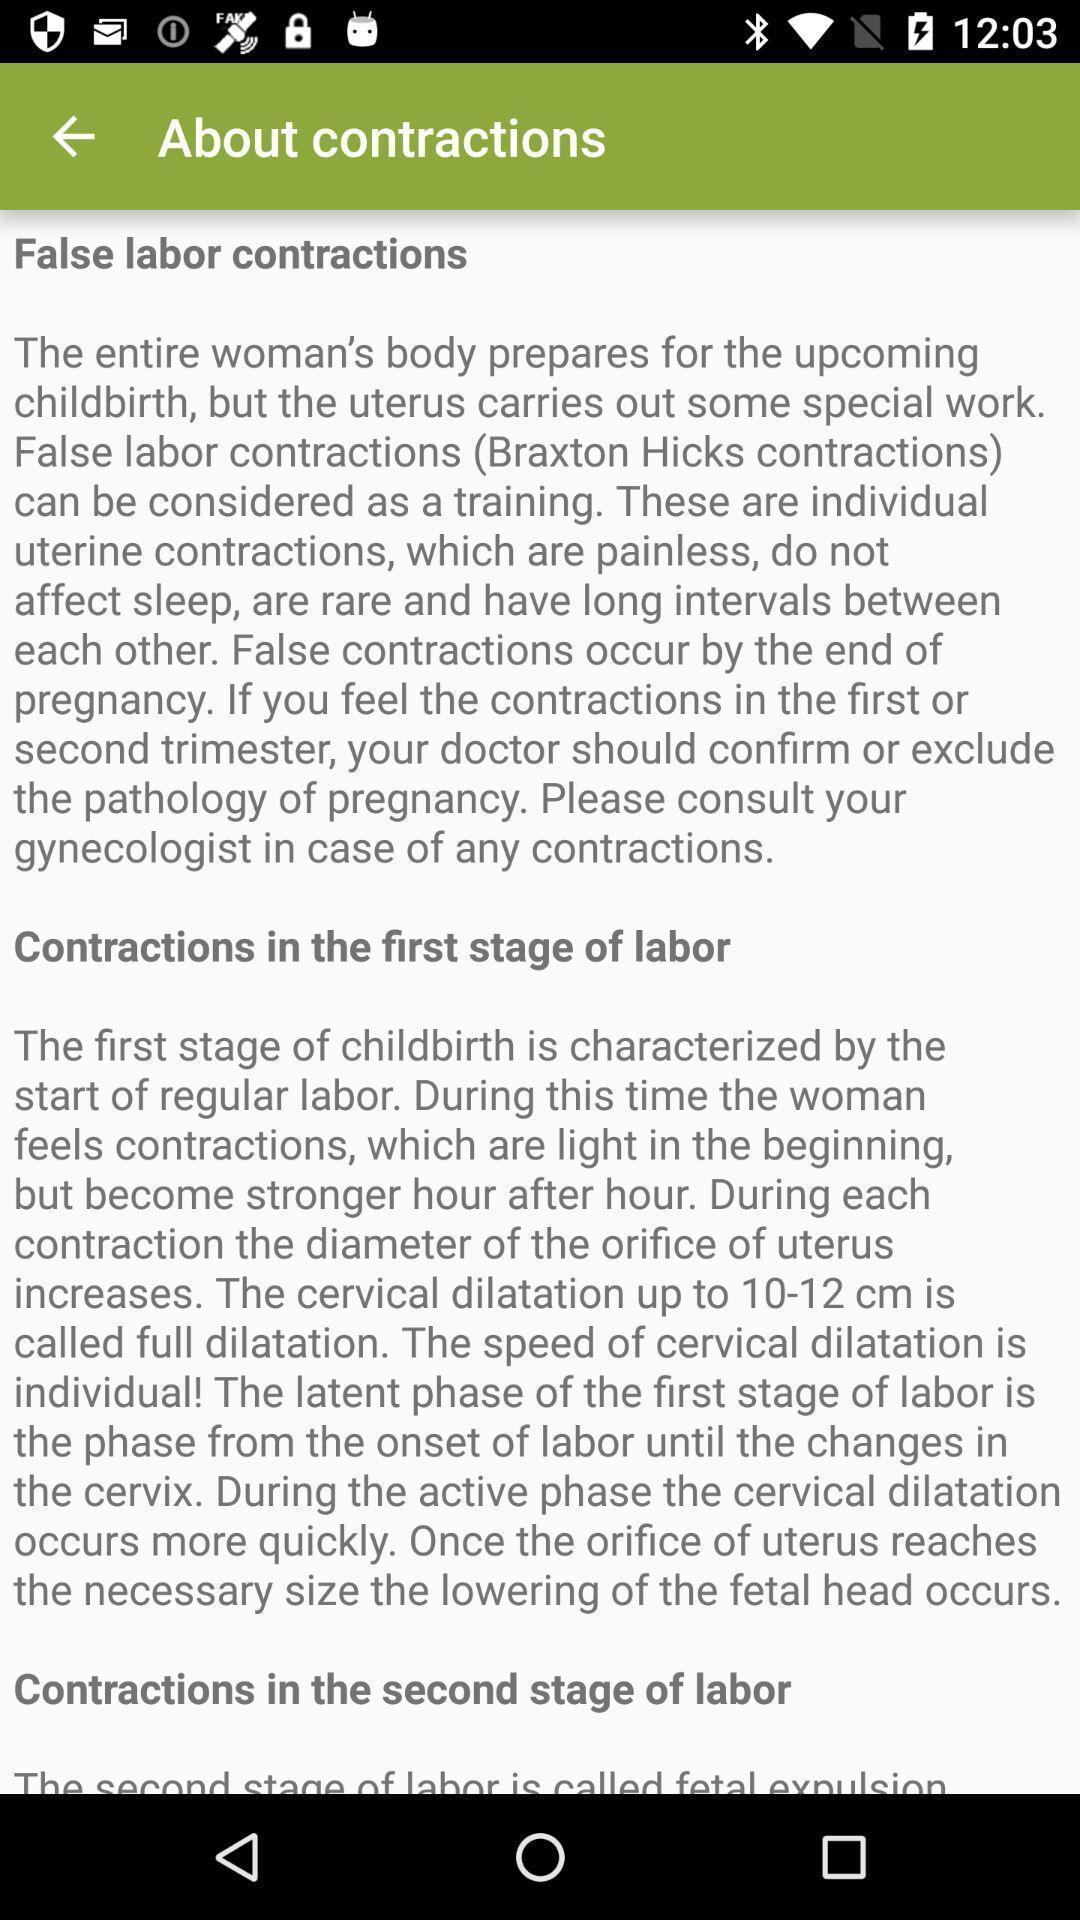Explain the elements present in this screenshot. Screen shows about contradictions in a featured app. 